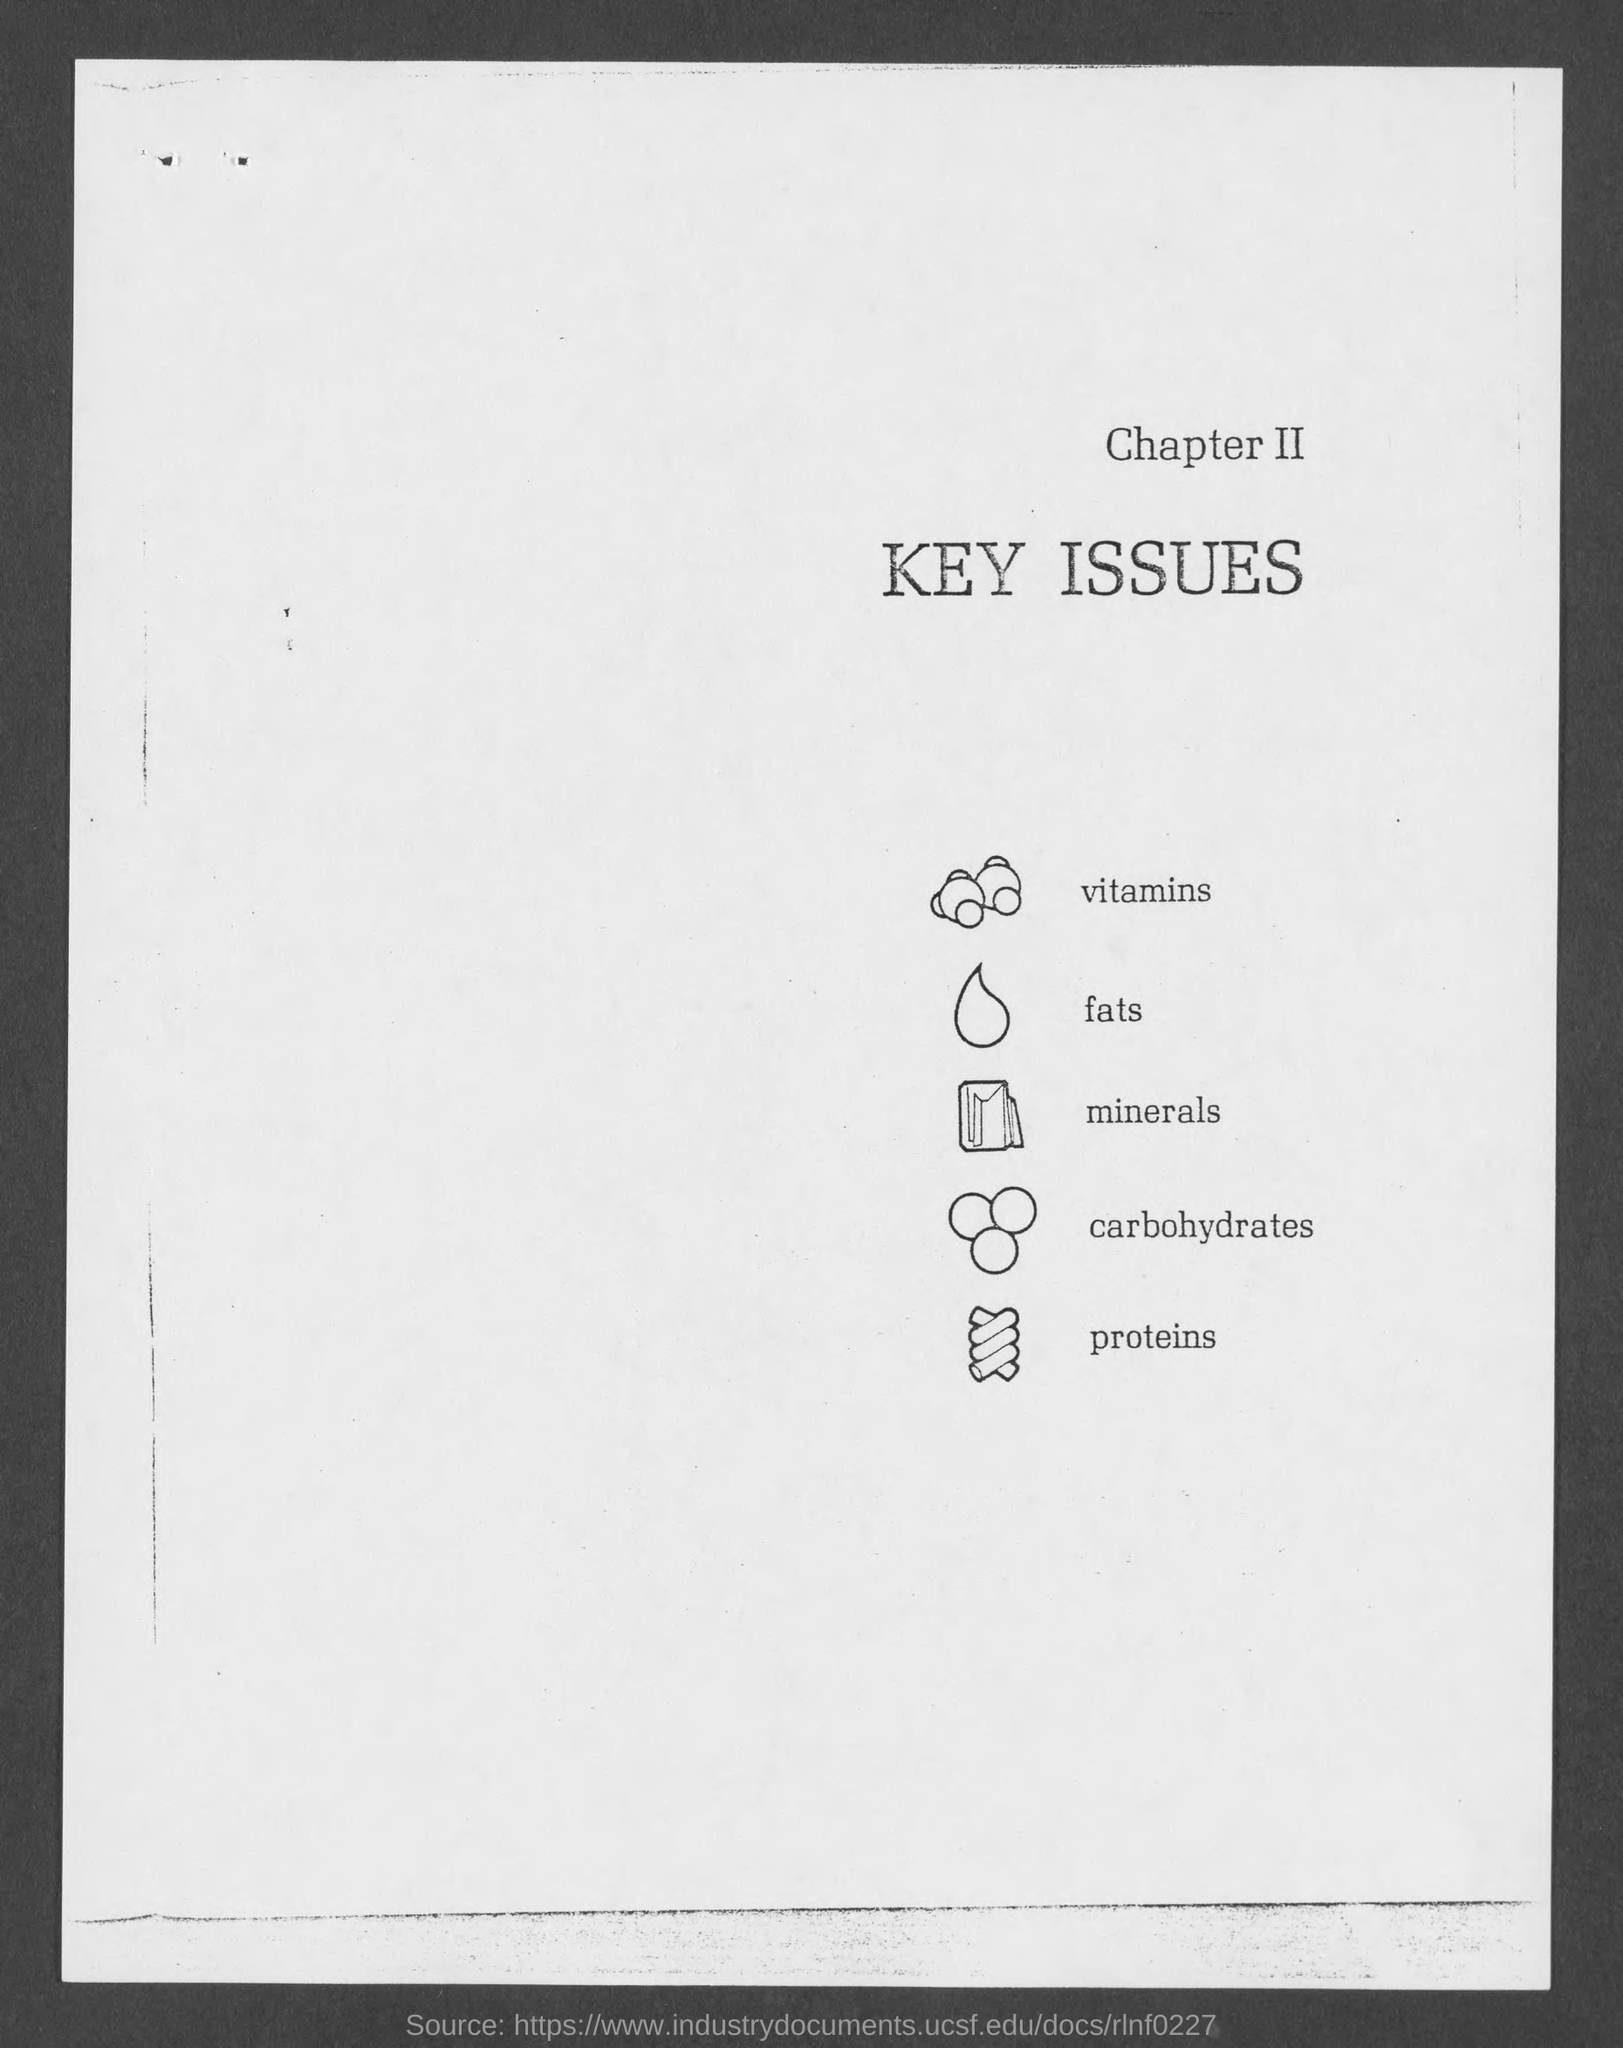Point out several critical features in this image. Chapter II addresses the key issues in the case, providing insight into the central concerns of the legal dispute. 